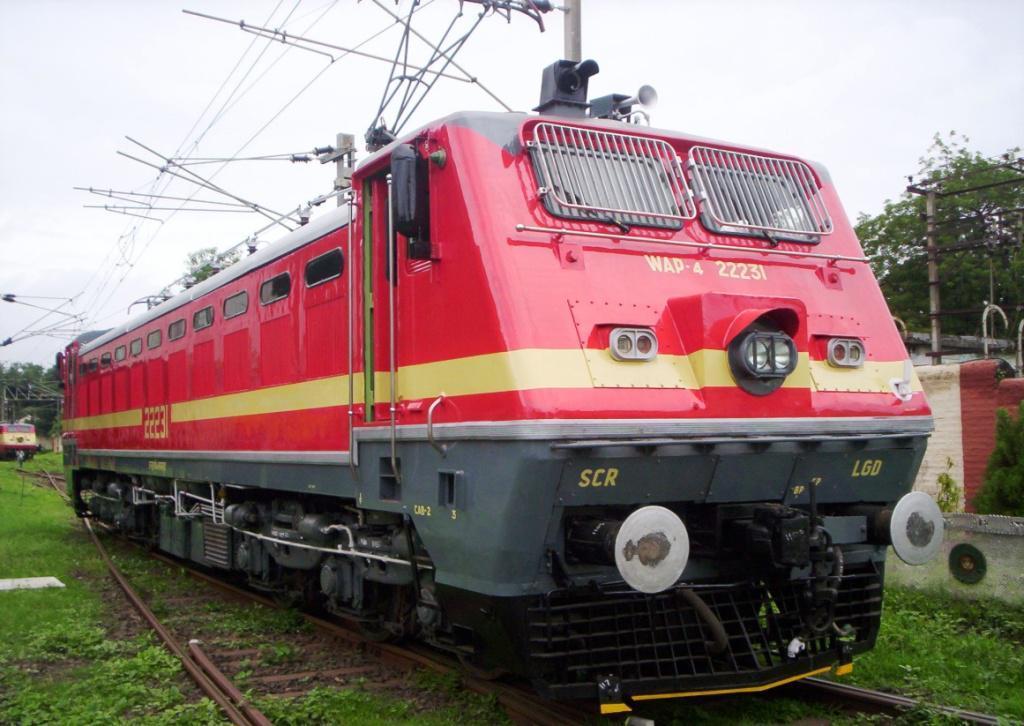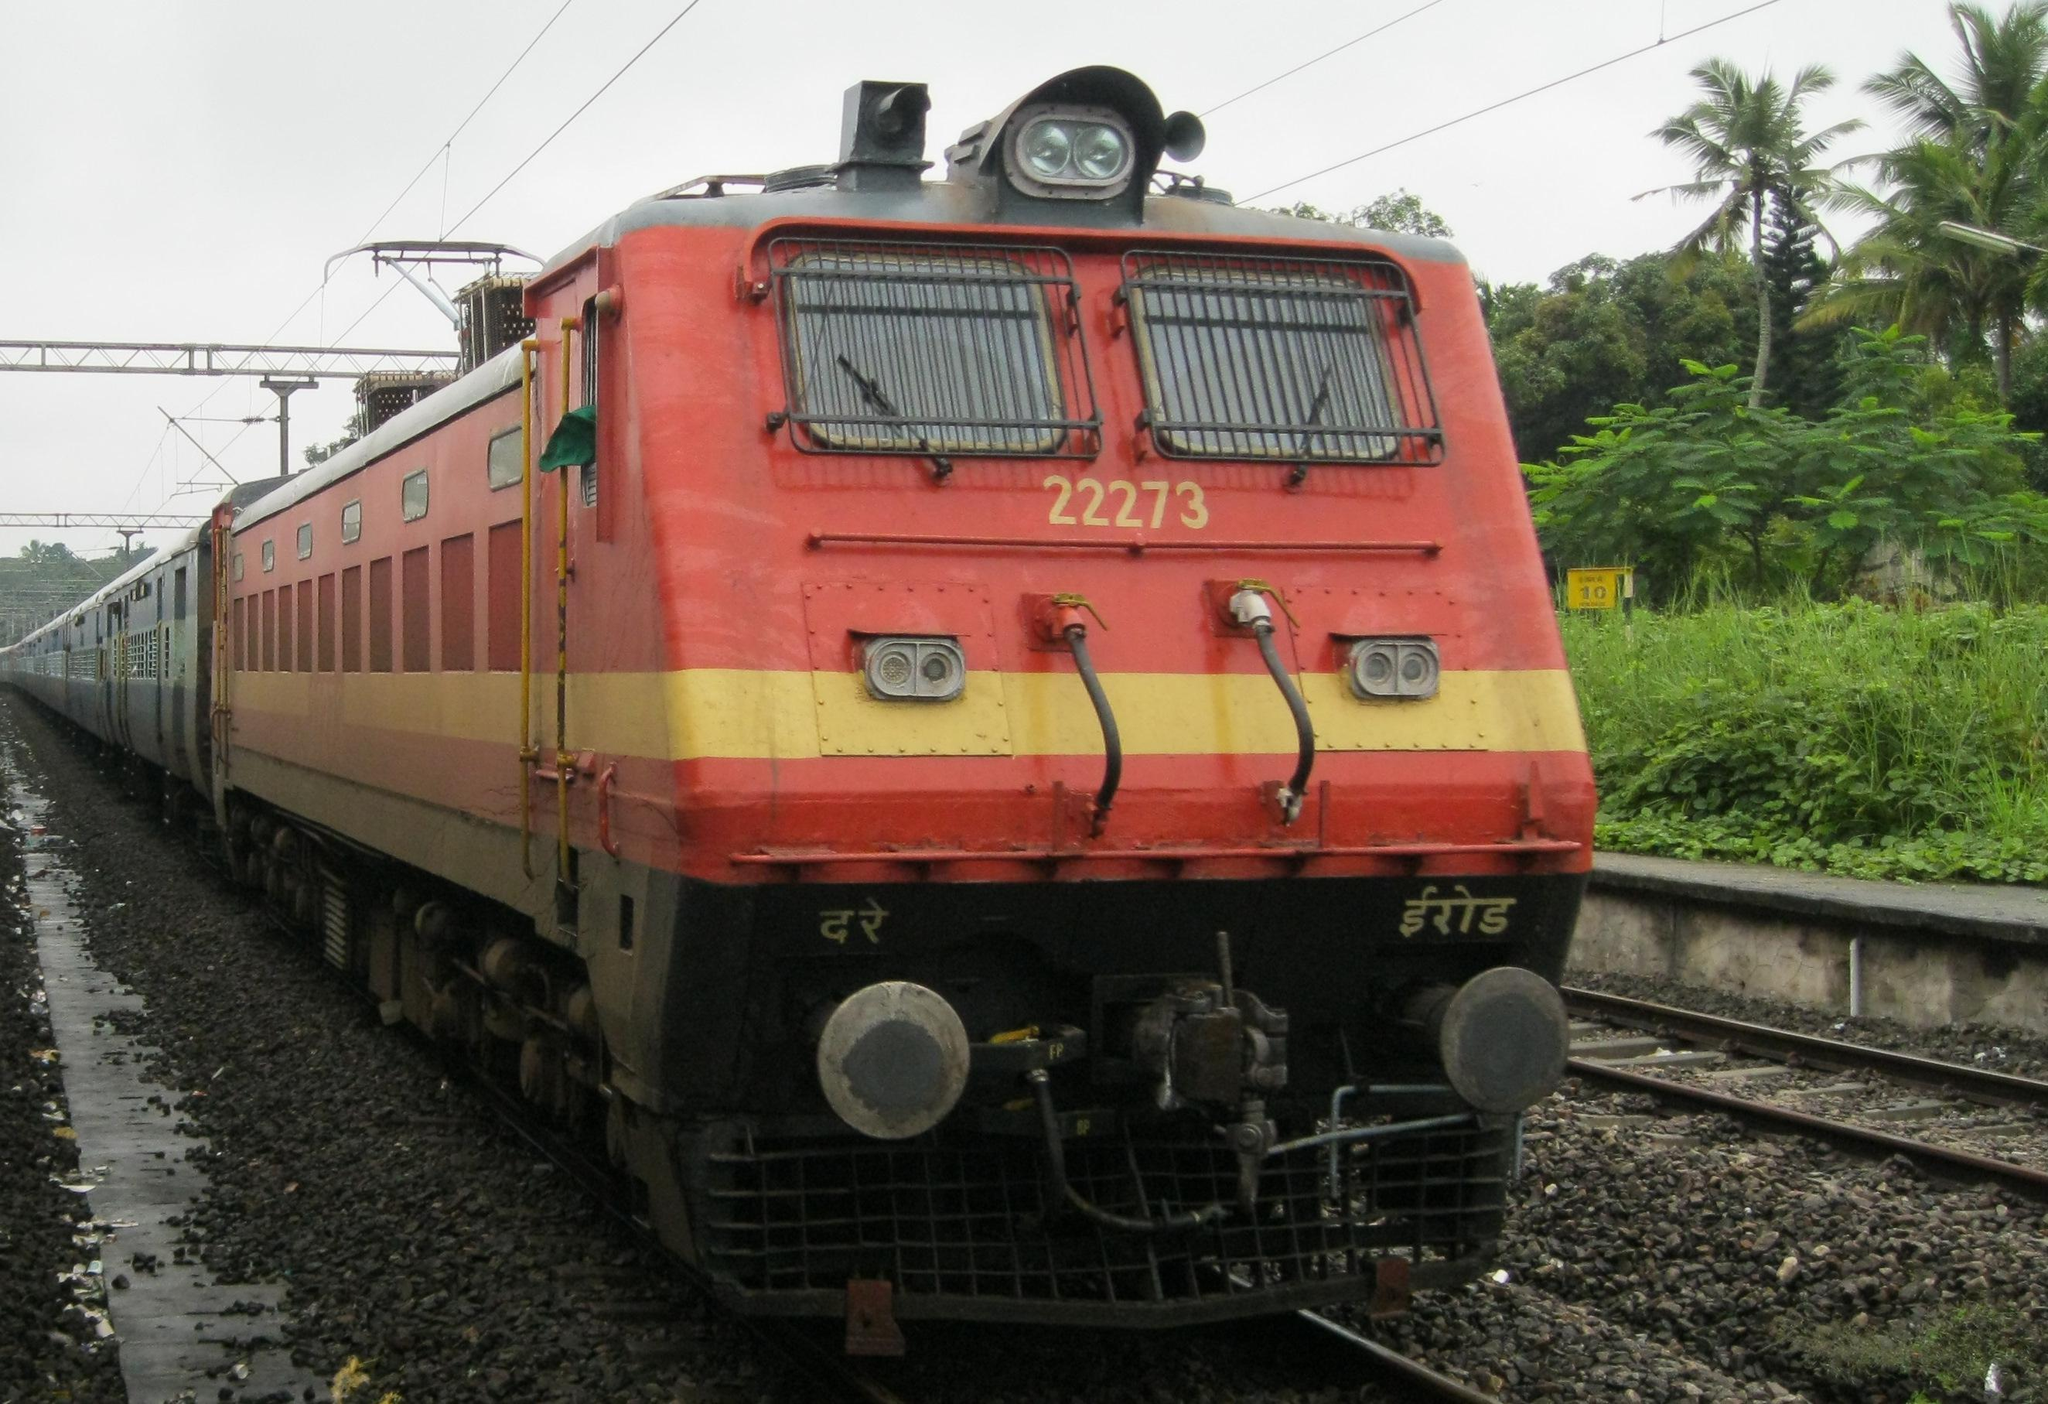The first image is the image on the left, the second image is the image on the right. For the images shown, is this caption "Both trains are predominately red headed in the same direction." true? Answer yes or no. Yes. The first image is the image on the left, the second image is the image on the right. For the images shown, is this caption "Each image shows a predominantly orange-red train, and no train has its front aimed leftward." true? Answer yes or no. Yes. 